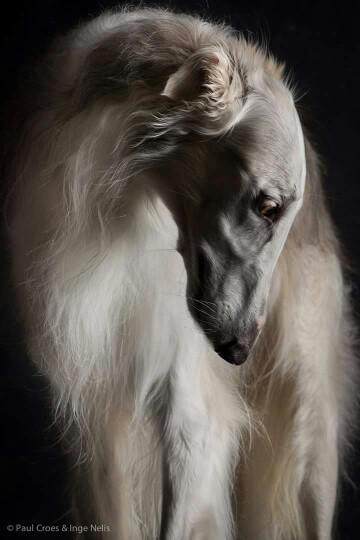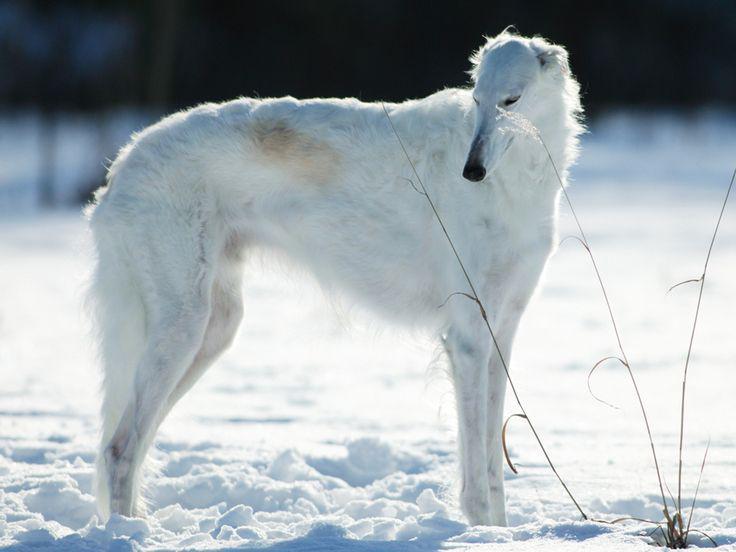The first image is the image on the left, the second image is the image on the right. For the images displayed, is the sentence "Each image contains one silky haired white afghan hound, and one dog has his head lowered to the left." factually correct? Answer yes or no. Yes. The first image is the image on the left, the second image is the image on the right. For the images displayed, is the sentence "One of the dogs is in the snow." factually correct? Answer yes or no. Yes. 